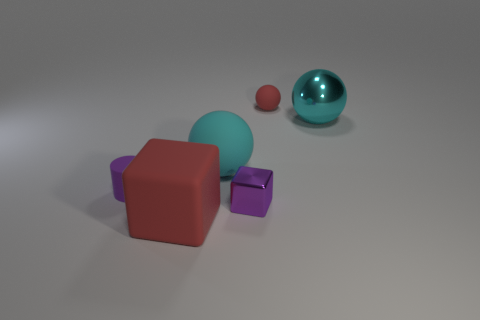Does this arrangement suggest any particular theme? The minimalist arrangement and contrasting colors may suggest a theme of simplicity and order, with each object neatly placed and given space to stand out. 